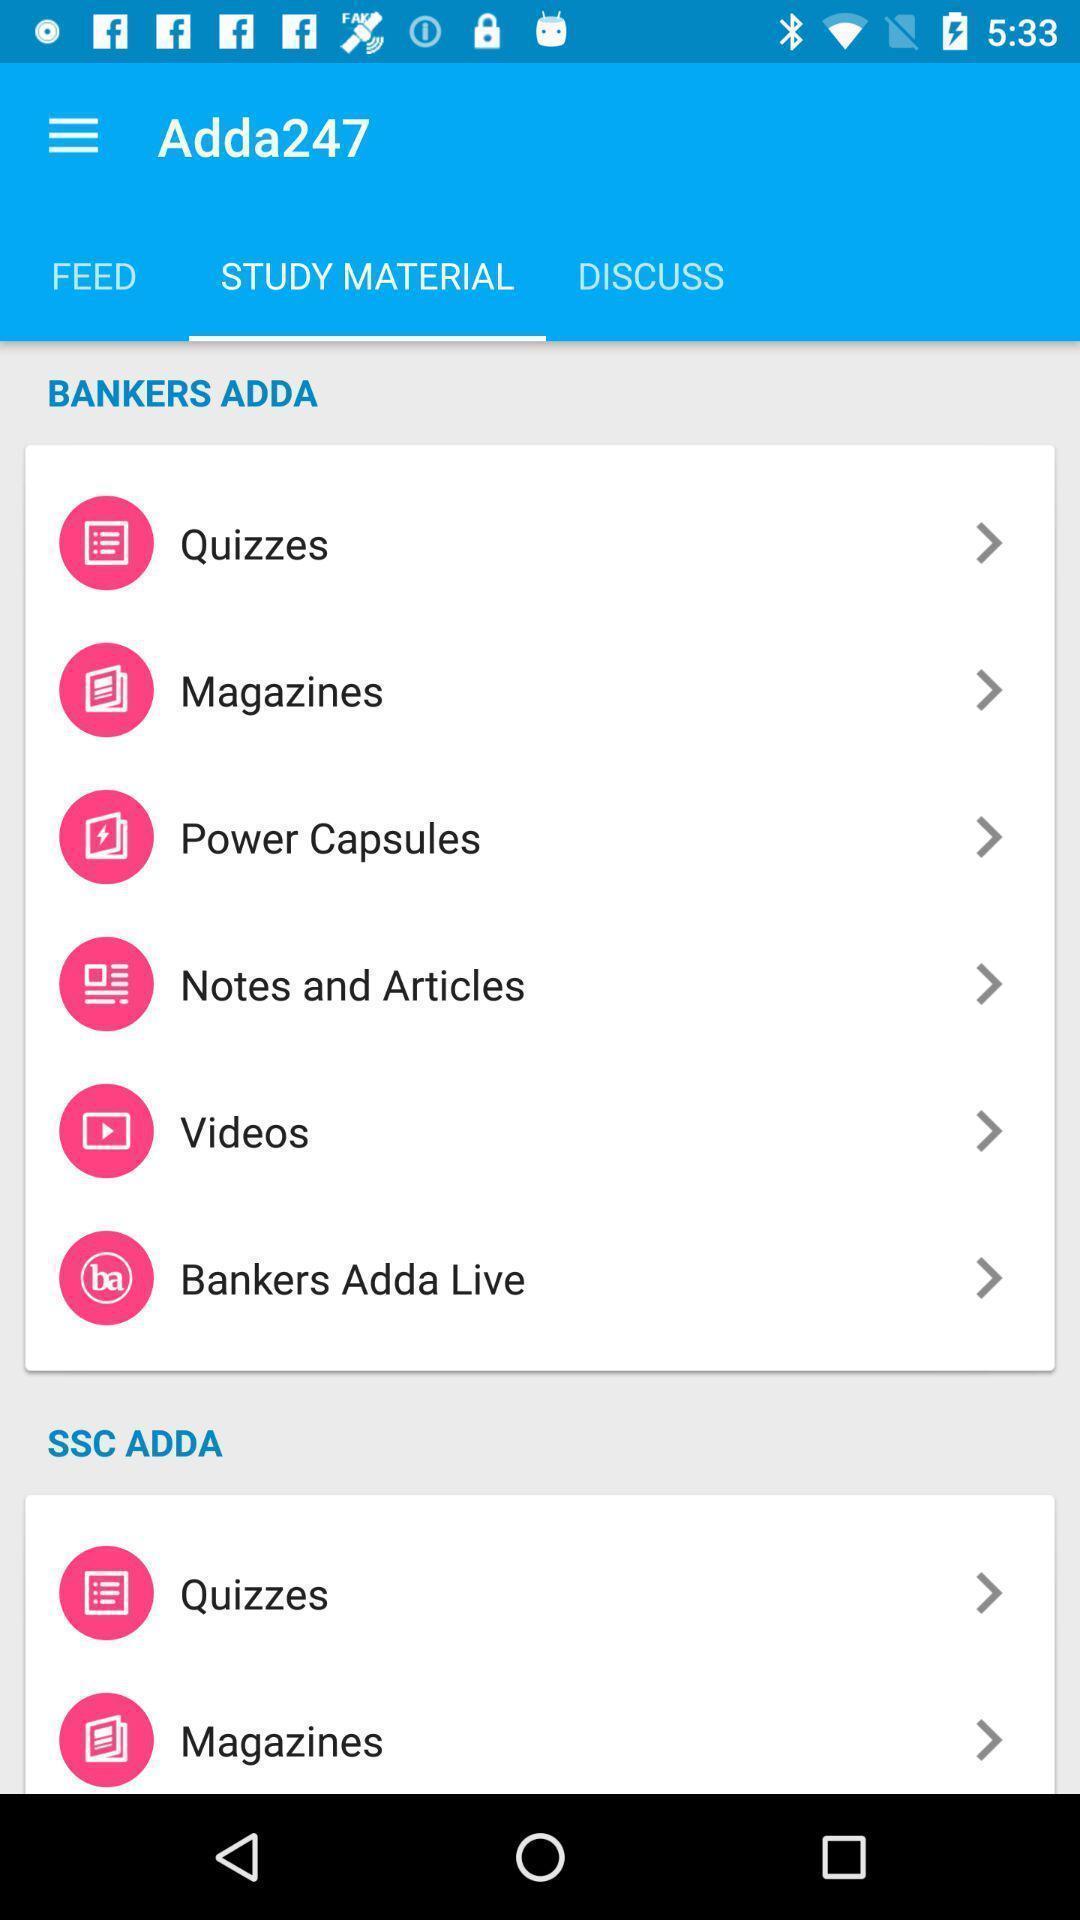Please provide a description for this image. Screen shows different study materials. 